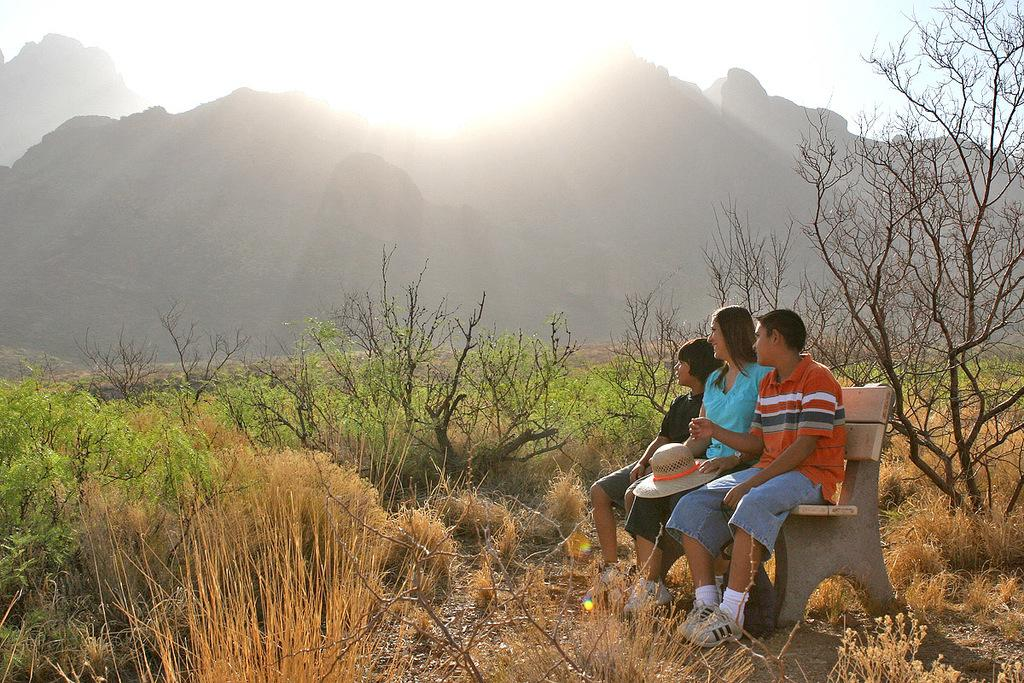How many people are sitting on the bench in the image? There are three people sitting on a bench in the image. What type of clothing accessory can be seen in the image? There is a hat in the image. What type of vegetation is present at the bottom of the image? Grass is present at the bottom of the image. What type of natural features are visible in the image? Trees and hills are visible in the image. What is visible in the background of the image? The sky is visible in the background of the image. What type of ship can be seen sailing in the background of the image? There is no ship present in the image; it features a bench with three people, a hat, grass, trees, hills, and the sky. What is the breakfast menu for the people sitting on the bench in the image? There is no information about breakfast in the image; it only shows the people sitting on the bench, a hat, grass, trees, hills, and the sky. 